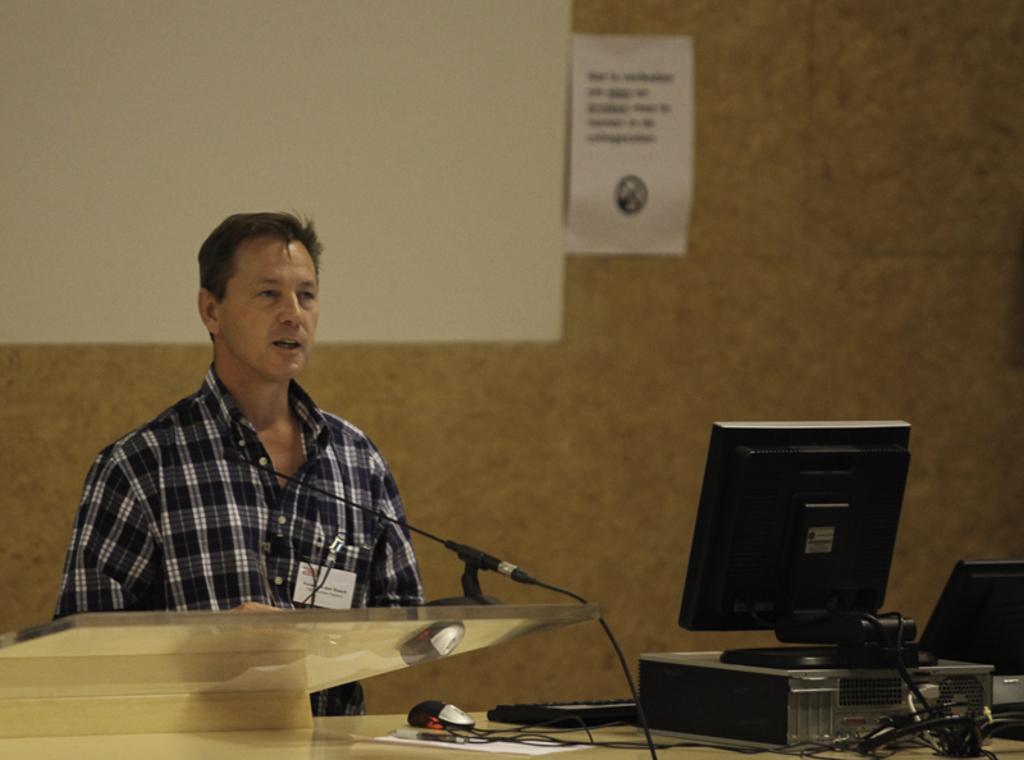How would you summarize this image in a sentence or two? In this image there is a person, in front of the person there is a podium, beside the podium there is a mic, computer, cables, mouse, keyboard, pen, paper and some other objects, behind him on the wall there is a screen and a poster with text and symbol. 